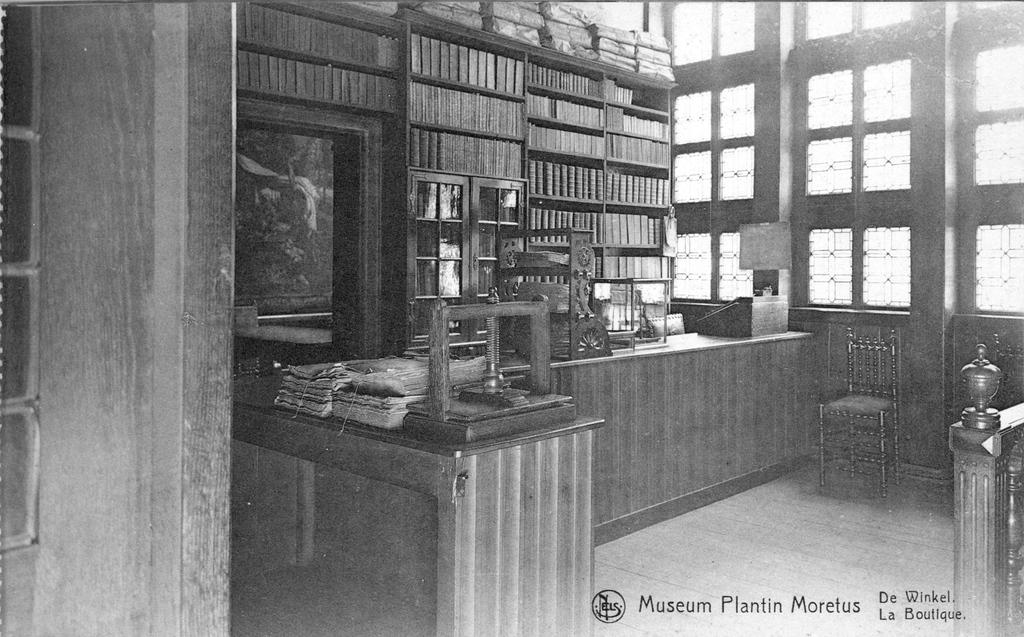<image>
Present a compact description of the photo's key features. a black and white photo of the museum plantin morfeus. 